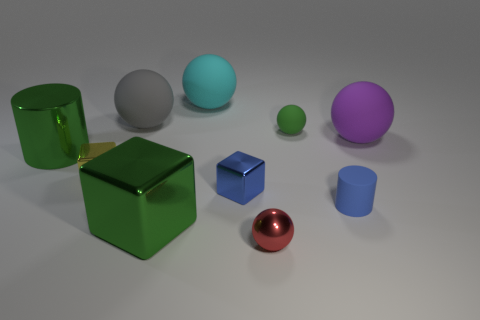Subtract all tiny metallic cubes. How many cubes are left? 1 Subtract all red balls. How many balls are left? 4 Subtract all purple spheres. Subtract all cyan blocks. How many spheres are left? 4 Subtract all cylinders. How many objects are left? 8 Subtract all tiny yellow shiny objects. Subtract all matte things. How many objects are left? 4 Add 2 green things. How many green things are left? 5 Add 4 large cyan spheres. How many large cyan spheres exist? 5 Subtract 0 brown cylinders. How many objects are left? 10 